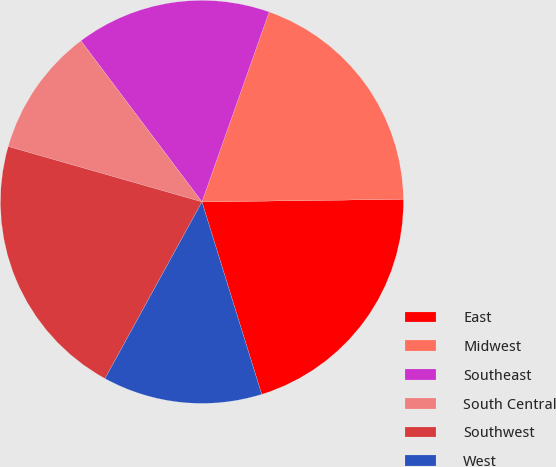Convert chart to OTSL. <chart><loc_0><loc_0><loc_500><loc_500><pie_chart><fcel>East<fcel>Midwest<fcel>Southeast<fcel>South Central<fcel>Southwest<fcel>West<nl><fcel>20.41%<fcel>19.38%<fcel>15.67%<fcel>10.31%<fcel>21.44%<fcel>12.78%<nl></chart> 